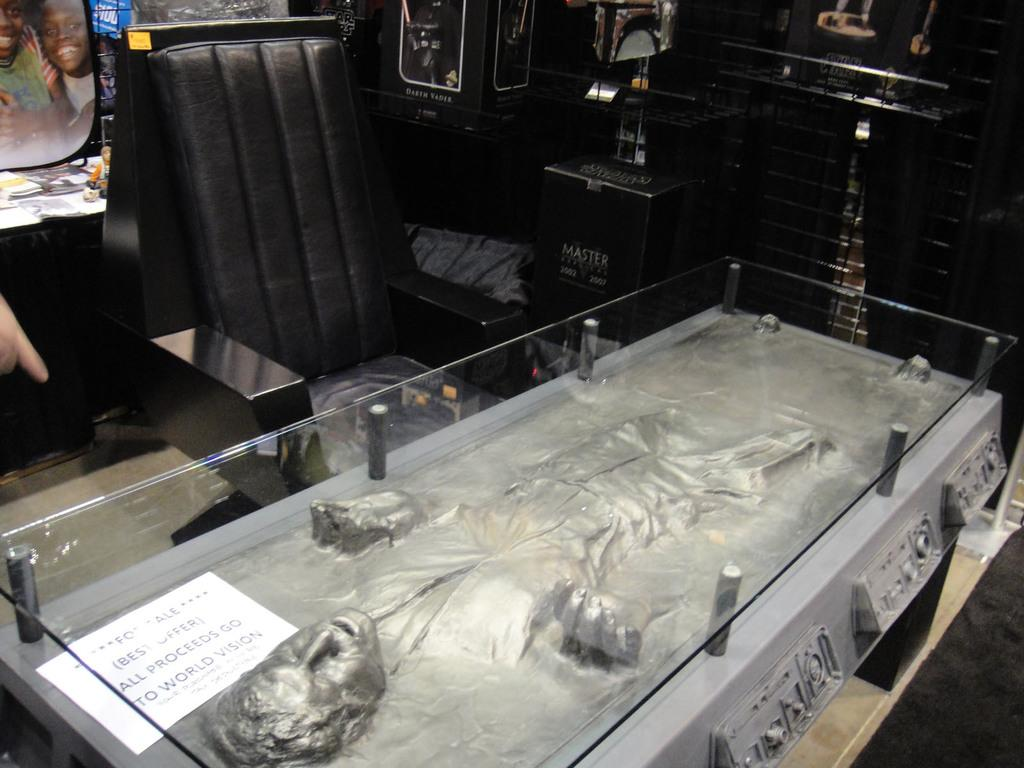What is inside the box in the image? There is a statue of a person in a box. What is used to cover the statue? The statue is accompanied by a sheet. How is the box containing the statue protected? The box is covered with a glass. What type of chair is visible in the image? There is a black color chair in the image. What other objects can be seen in the background of the image? There are other objects in the background of the image. How does the zephyr affect the statue in the image? There is no mention of a zephyr in the image, so it cannot affect the statue. 